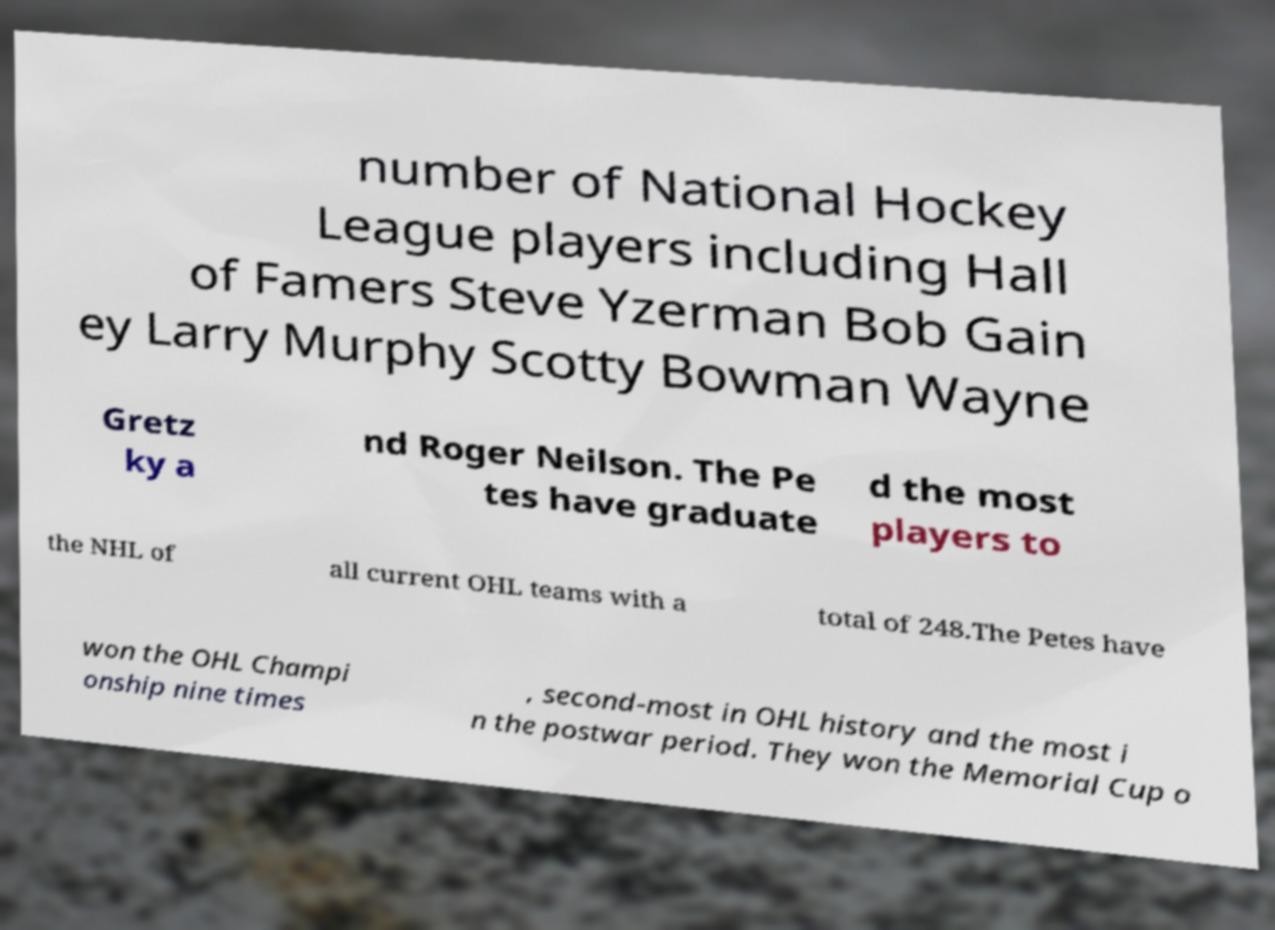Please identify and transcribe the text found in this image. number of National Hockey League players including Hall of Famers Steve Yzerman Bob Gain ey Larry Murphy Scotty Bowman Wayne Gretz ky a nd Roger Neilson. The Pe tes have graduate d the most players to the NHL of all current OHL teams with a total of 248.The Petes have won the OHL Champi onship nine times , second-most in OHL history and the most i n the postwar period. They won the Memorial Cup o 